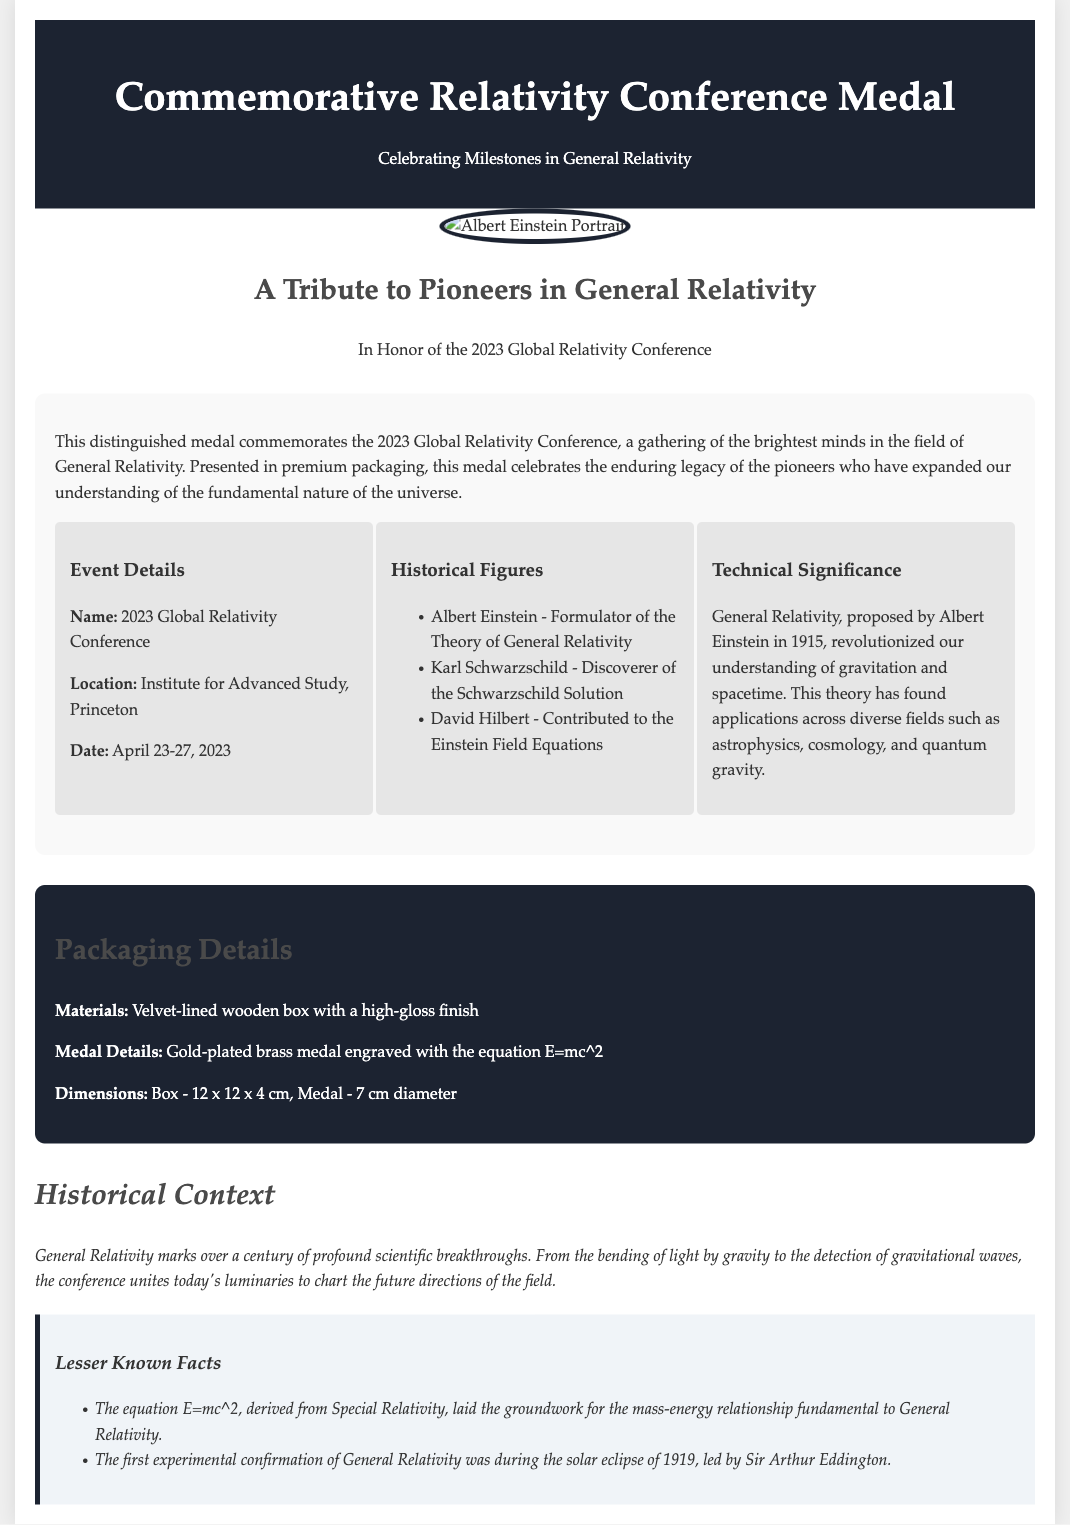What is the name of the conference? The document specifies the name of the conference as the "2023 Global Relativity Conference."
Answer: 2023 Global Relativity Conference Where is the conference located? The document provides the location as the "Institute for Advanced Study, Princeton."
Answer: Institute for Advanced Study, Princeton What is the date of the conference? The document lists the date of the conference as "April 23-27, 2023."
Answer: April 23-27, 2023 Who formulated the Theory of General Relativity? The document identifies Albert Einstein as the person who formulated the Theory of General Relativity.
Answer: Albert Einstein What materials are used for the packaging? The document mentions the packaging materials as a "velvet-lined wooden box with a high-gloss finish."
Answer: Velvet-lined wooden box with a high-gloss finish How is the medal engraved? The document states the medal is engraved with the equation "E=mc^2."
Answer: E=mc^2 What significant event confirmed General Relativity for the first time? The document notes the first experimental confirmation was during the "solar eclipse of 1919."
Answer: Solar eclipse of 1919 What is the diameter of the medal? The document states the diameter of the medal is "7 cm."
Answer: 7 cm What is a key significance of General Relativity mentioned? The document describes a significant aspect as the "bending of light by gravity."
Answer: Bending of light by gravity 